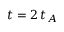Convert formula to latex. <formula><loc_0><loc_0><loc_500><loc_500>t = 2 \, t _ { A }</formula> 